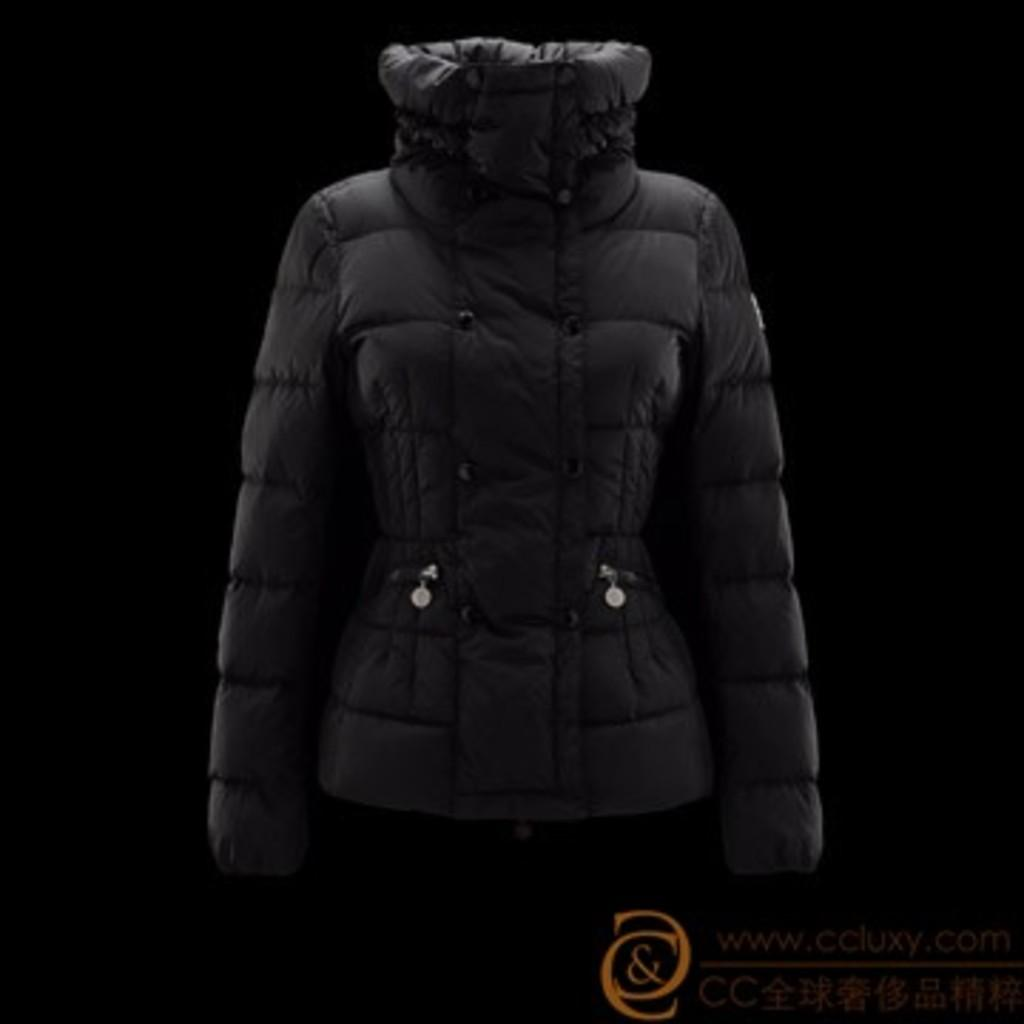What is the main subject of the image? The main subject of the image is a coat. Where is the coat located in the image? The coat is in the middle of the image. What else can be seen at the bottom of the image? There is a logo with some text at the bottom of the image. What type of development can be seen taking place in the image? There is no development taking place in the image; it features a coat and a logo with some text. Can you hear any thunder in the image? There is no sound in the image, so it is impossible to hear any thunder. 